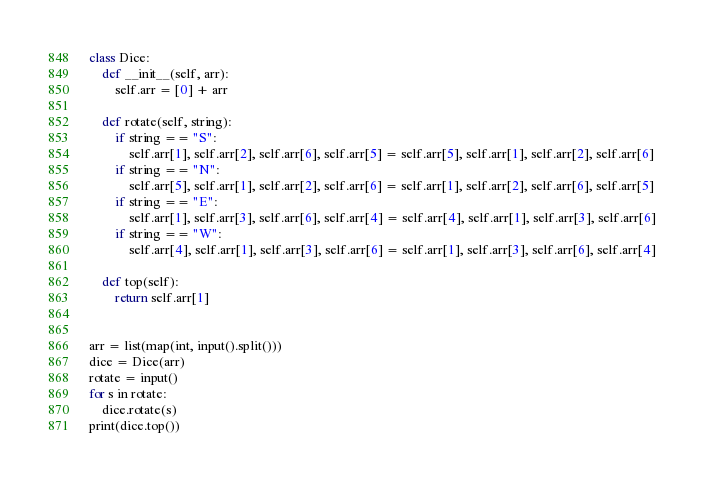Convert code to text. <code><loc_0><loc_0><loc_500><loc_500><_Python_>class Dice:
    def __init__(self, arr):
        self.arr = [0] + arr
        
    def rotate(self, string):
        if string == "S":
            self.arr[1], self.arr[2], self.arr[6], self.arr[5] = self.arr[5], self.arr[1], self.arr[2], self.arr[6]
        if string == "N":
            self.arr[5], self.arr[1], self.arr[2], self.arr[6] = self.arr[1], self.arr[2], self.arr[6], self.arr[5]
        if string == "E":
            self.arr[1], self.arr[3], self.arr[6], self.arr[4] = self.arr[4], self.arr[1], self.arr[3], self.arr[6]
        if string == "W":
            self.arr[4], self.arr[1], self.arr[3], self.arr[6] = self.arr[1], self.arr[3], self.arr[6], self.arr[4]

    def top(self):
        return self.arr[1]


arr = list(map(int, input().split()))
dice = Dice(arr)
rotate = input()
for s in rotate:
    dice.rotate(s)
print(dice.top())

</code> 